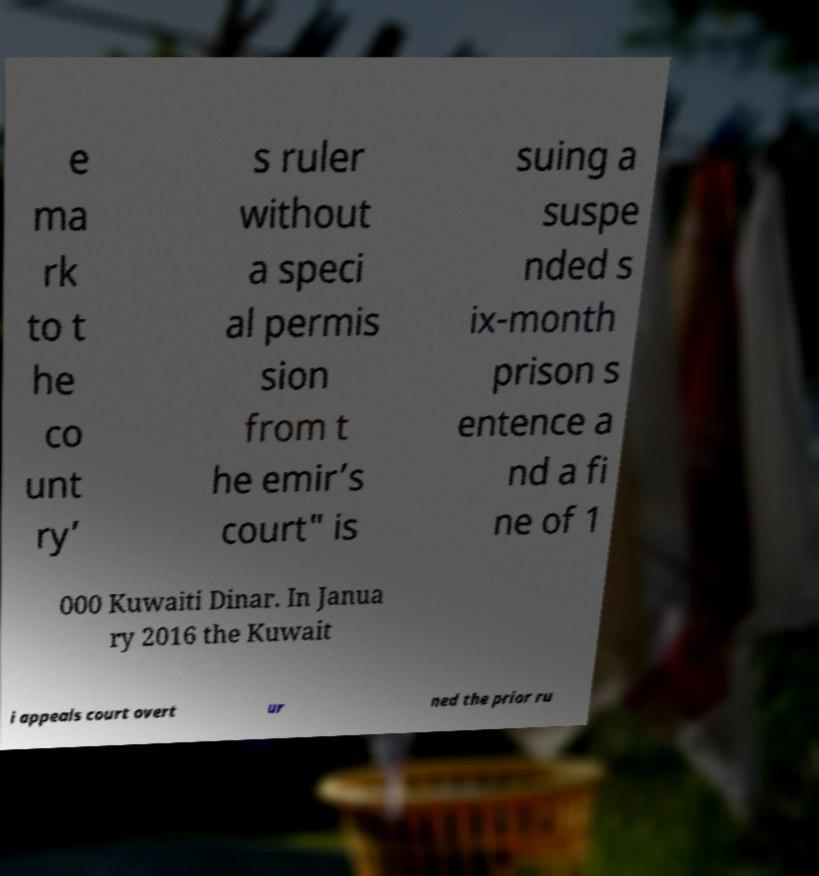There's text embedded in this image that I need extracted. Can you transcribe it verbatim? e ma rk to t he co unt ry’ s ruler without a speci al permis sion from t he emir’s court" is suing a suspe nded s ix-month prison s entence a nd a fi ne of 1 000 Kuwaiti Dinar. In Janua ry 2016 the Kuwait i appeals court overt ur ned the prior ru 